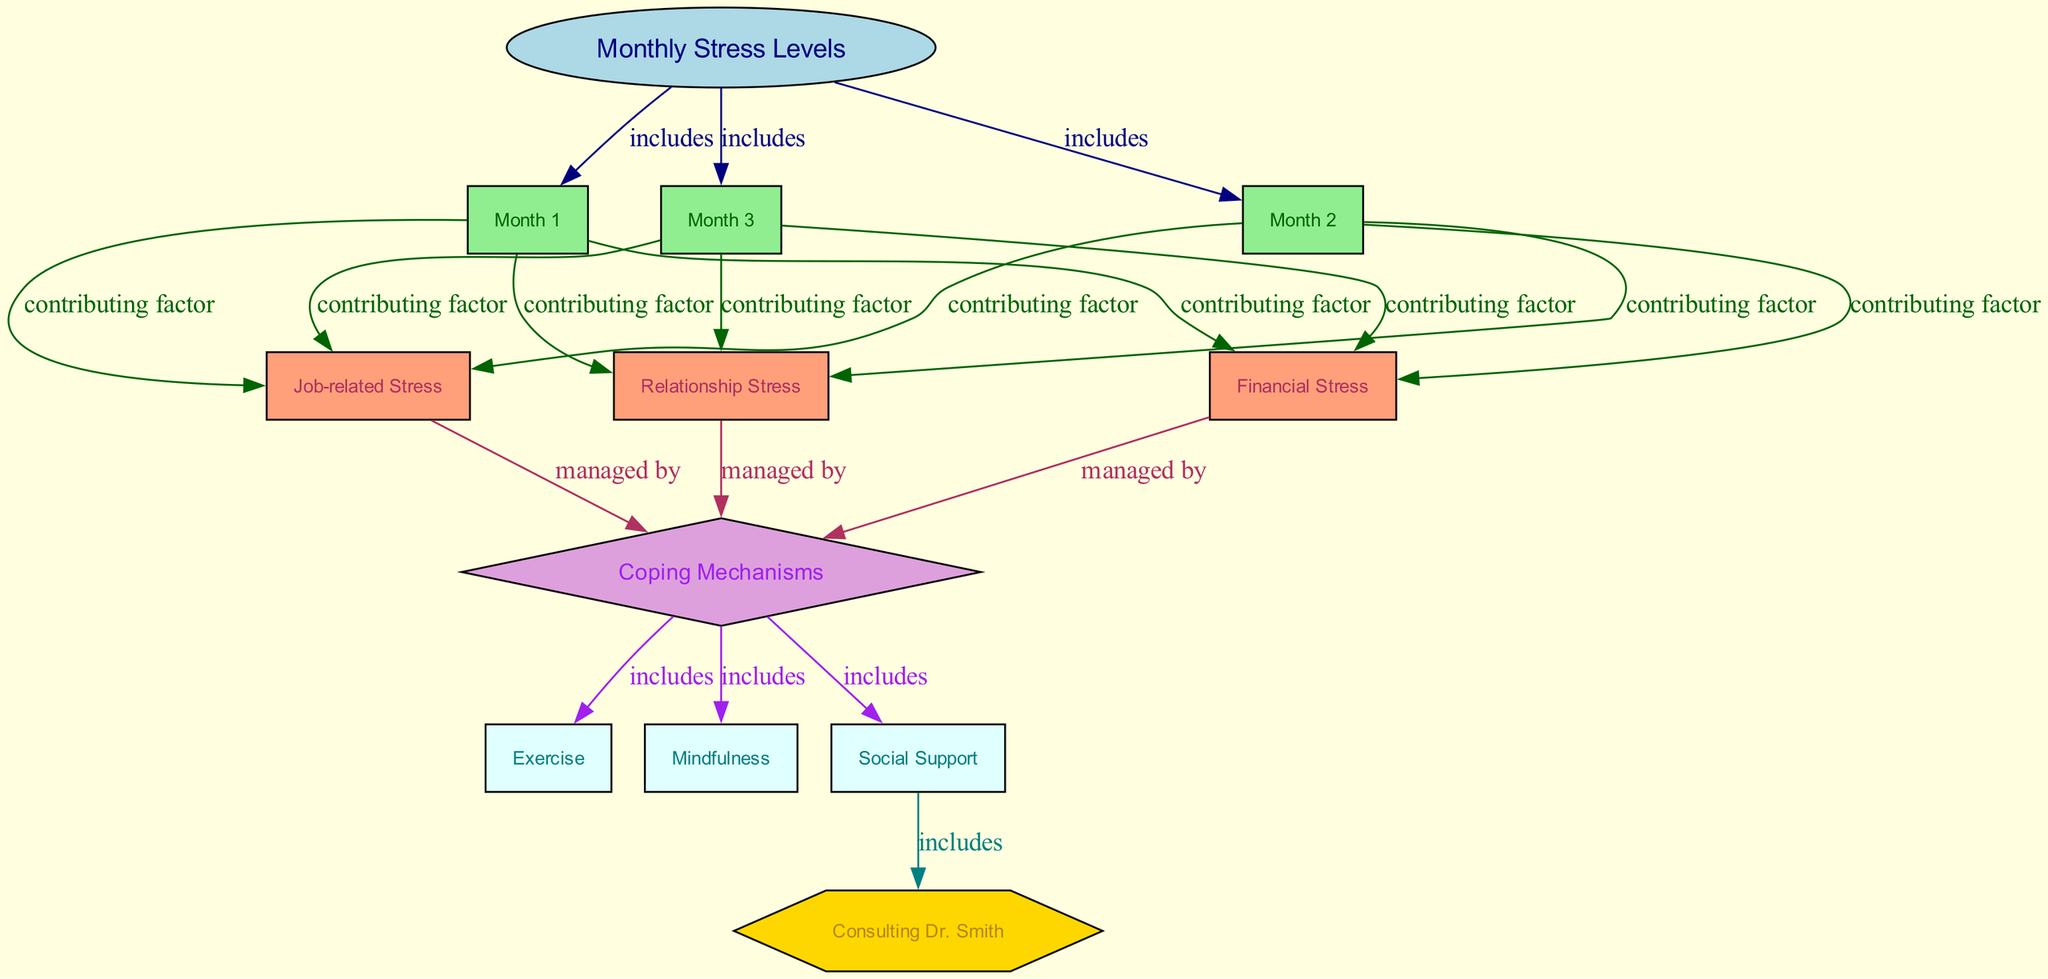What are the three months illustrated in the diagram? The diagram includes three nodes representing the months: Month 1 (January), Month 2 (February), and Month 3 (March). These nodes are directly included under the "Monthly Stress Levels" node indicating their relevance.
Answer: January, February, March What types of stress contribute to the levels recorded in Month 1? The diagram shows three contributing factors linked to Month 1: Job-related Stress, Financial Stress, and Relationship Stress. These factors are specifically listed as contributing factors to the stress levels for that month.
Answer: Job-related Stress, Financial Stress, Relationship Stress What is the main category that encompasses Exercise, Mindfulness, and Social Support? The three coping strategies—Exercise, Mindfulness, and Social Support—are all included under the "Coping Mechanisms" node, indicating they are part of a larger category that addresses stress management.
Answer: Coping Mechanisms Which coping mechanism is directly associated with the retired doctor's advice? The diagram indicates that Social Support is linked to Consulting Dr. Smith, implying that seeking help from friends and family can include engaging the retired doctor for advice.
Answer: Social Support How many total nodes are there in the diagram? The diagram has a total of 12 nodes, which include one main topic node, three month nodes, three stress types, one coping mechanisms node, and four specific coping strategy nodes.
Answer: 12 What is the relationship between Job-related Stress and Coping Mechanisms? Job-related Stress is shown to be a contributing factor that is managed by Coping Mechanisms, indicating that the stress from job pressures can be addressed through various coping strategies outlined in the diagram.
Answer: managed by Which month shows the highest likelihood of being influenced by financial stress? Given that financial stress is indicated as a contributing factor for all three months, but is directly linked to the stress levels recorded in Month 2 (February) along with other stress types, one could reason that it is equally significant throughout. Recognizing that all months include it but showing a unique mention suggests that February is critical.
Answer: February How many edges represent the connection between contributing factors and coping mechanisms? There are three edges showing the relationship where Job-related Stress, Financial Stress, and Relationship Stress manage the Coping Mechanisms, indicating the influence of these stress types on the strategies employed to cope.
Answer: 3 